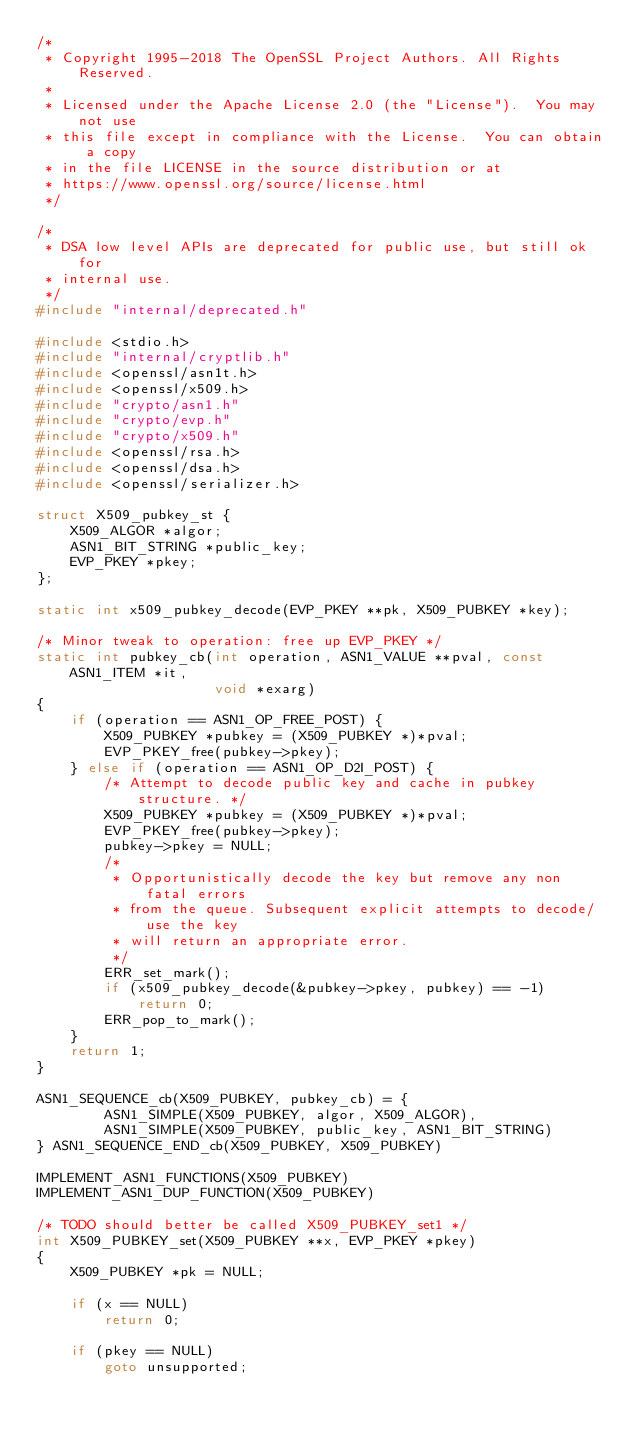Convert code to text. <code><loc_0><loc_0><loc_500><loc_500><_C_>/*
 * Copyright 1995-2018 The OpenSSL Project Authors. All Rights Reserved.
 *
 * Licensed under the Apache License 2.0 (the "License").  You may not use
 * this file except in compliance with the License.  You can obtain a copy
 * in the file LICENSE in the source distribution or at
 * https://www.openssl.org/source/license.html
 */

/*
 * DSA low level APIs are deprecated for public use, but still ok for
 * internal use.
 */
#include "internal/deprecated.h"

#include <stdio.h>
#include "internal/cryptlib.h"
#include <openssl/asn1t.h>
#include <openssl/x509.h>
#include "crypto/asn1.h"
#include "crypto/evp.h"
#include "crypto/x509.h"
#include <openssl/rsa.h>
#include <openssl/dsa.h>
#include <openssl/serializer.h>

struct X509_pubkey_st {
    X509_ALGOR *algor;
    ASN1_BIT_STRING *public_key;
    EVP_PKEY *pkey;
};

static int x509_pubkey_decode(EVP_PKEY **pk, X509_PUBKEY *key);

/* Minor tweak to operation: free up EVP_PKEY */
static int pubkey_cb(int operation, ASN1_VALUE **pval, const ASN1_ITEM *it,
                     void *exarg)
{
    if (operation == ASN1_OP_FREE_POST) {
        X509_PUBKEY *pubkey = (X509_PUBKEY *)*pval;
        EVP_PKEY_free(pubkey->pkey);
    } else if (operation == ASN1_OP_D2I_POST) {
        /* Attempt to decode public key and cache in pubkey structure. */
        X509_PUBKEY *pubkey = (X509_PUBKEY *)*pval;
        EVP_PKEY_free(pubkey->pkey);
        pubkey->pkey = NULL;
        /*
         * Opportunistically decode the key but remove any non fatal errors
         * from the queue. Subsequent explicit attempts to decode/use the key
         * will return an appropriate error.
         */
        ERR_set_mark();
        if (x509_pubkey_decode(&pubkey->pkey, pubkey) == -1)
            return 0;
        ERR_pop_to_mark();
    }
    return 1;
}

ASN1_SEQUENCE_cb(X509_PUBKEY, pubkey_cb) = {
        ASN1_SIMPLE(X509_PUBKEY, algor, X509_ALGOR),
        ASN1_SIMPLE(X509_PUBKEY, public_key, ASN1_BIT_STRING)
} ASN1_SEQUENCE_END_cb(X509_PUBKEY, X509_PUBKEY)

IMPLEMENT_ASN1_FUNCTIONS(X509_PUBKEY)
IMPLEMENT_ASN1_DUP_FUNCTION(X509_PUBKEY)

/* TODO should better be called X509_PUBKEY_set1 */
int X509_PUBKEY_set(X509_PUBKEY **x, EVP_PKEY *pkey)
{
    X509_PUBKEY *pk = NULL;

    if (x == NULL)
        return 0;

    if (pkey == NULL)
        goto unsupported;
</code> 